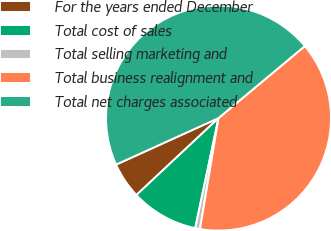<chart> <loc_0><loc_0><loc_500><loc_500><pie_chart><fcel>For the years ended December<fcel>Total cost of sales<fcel>Total selling marketing and<fcel>Total business realignment and<fcel>Total net charges associated<nl><fcel>5.2%<fcel>9.7%<fcel>0.69%<fcel>38.7%<fcel>45.72%<nl></chart> 